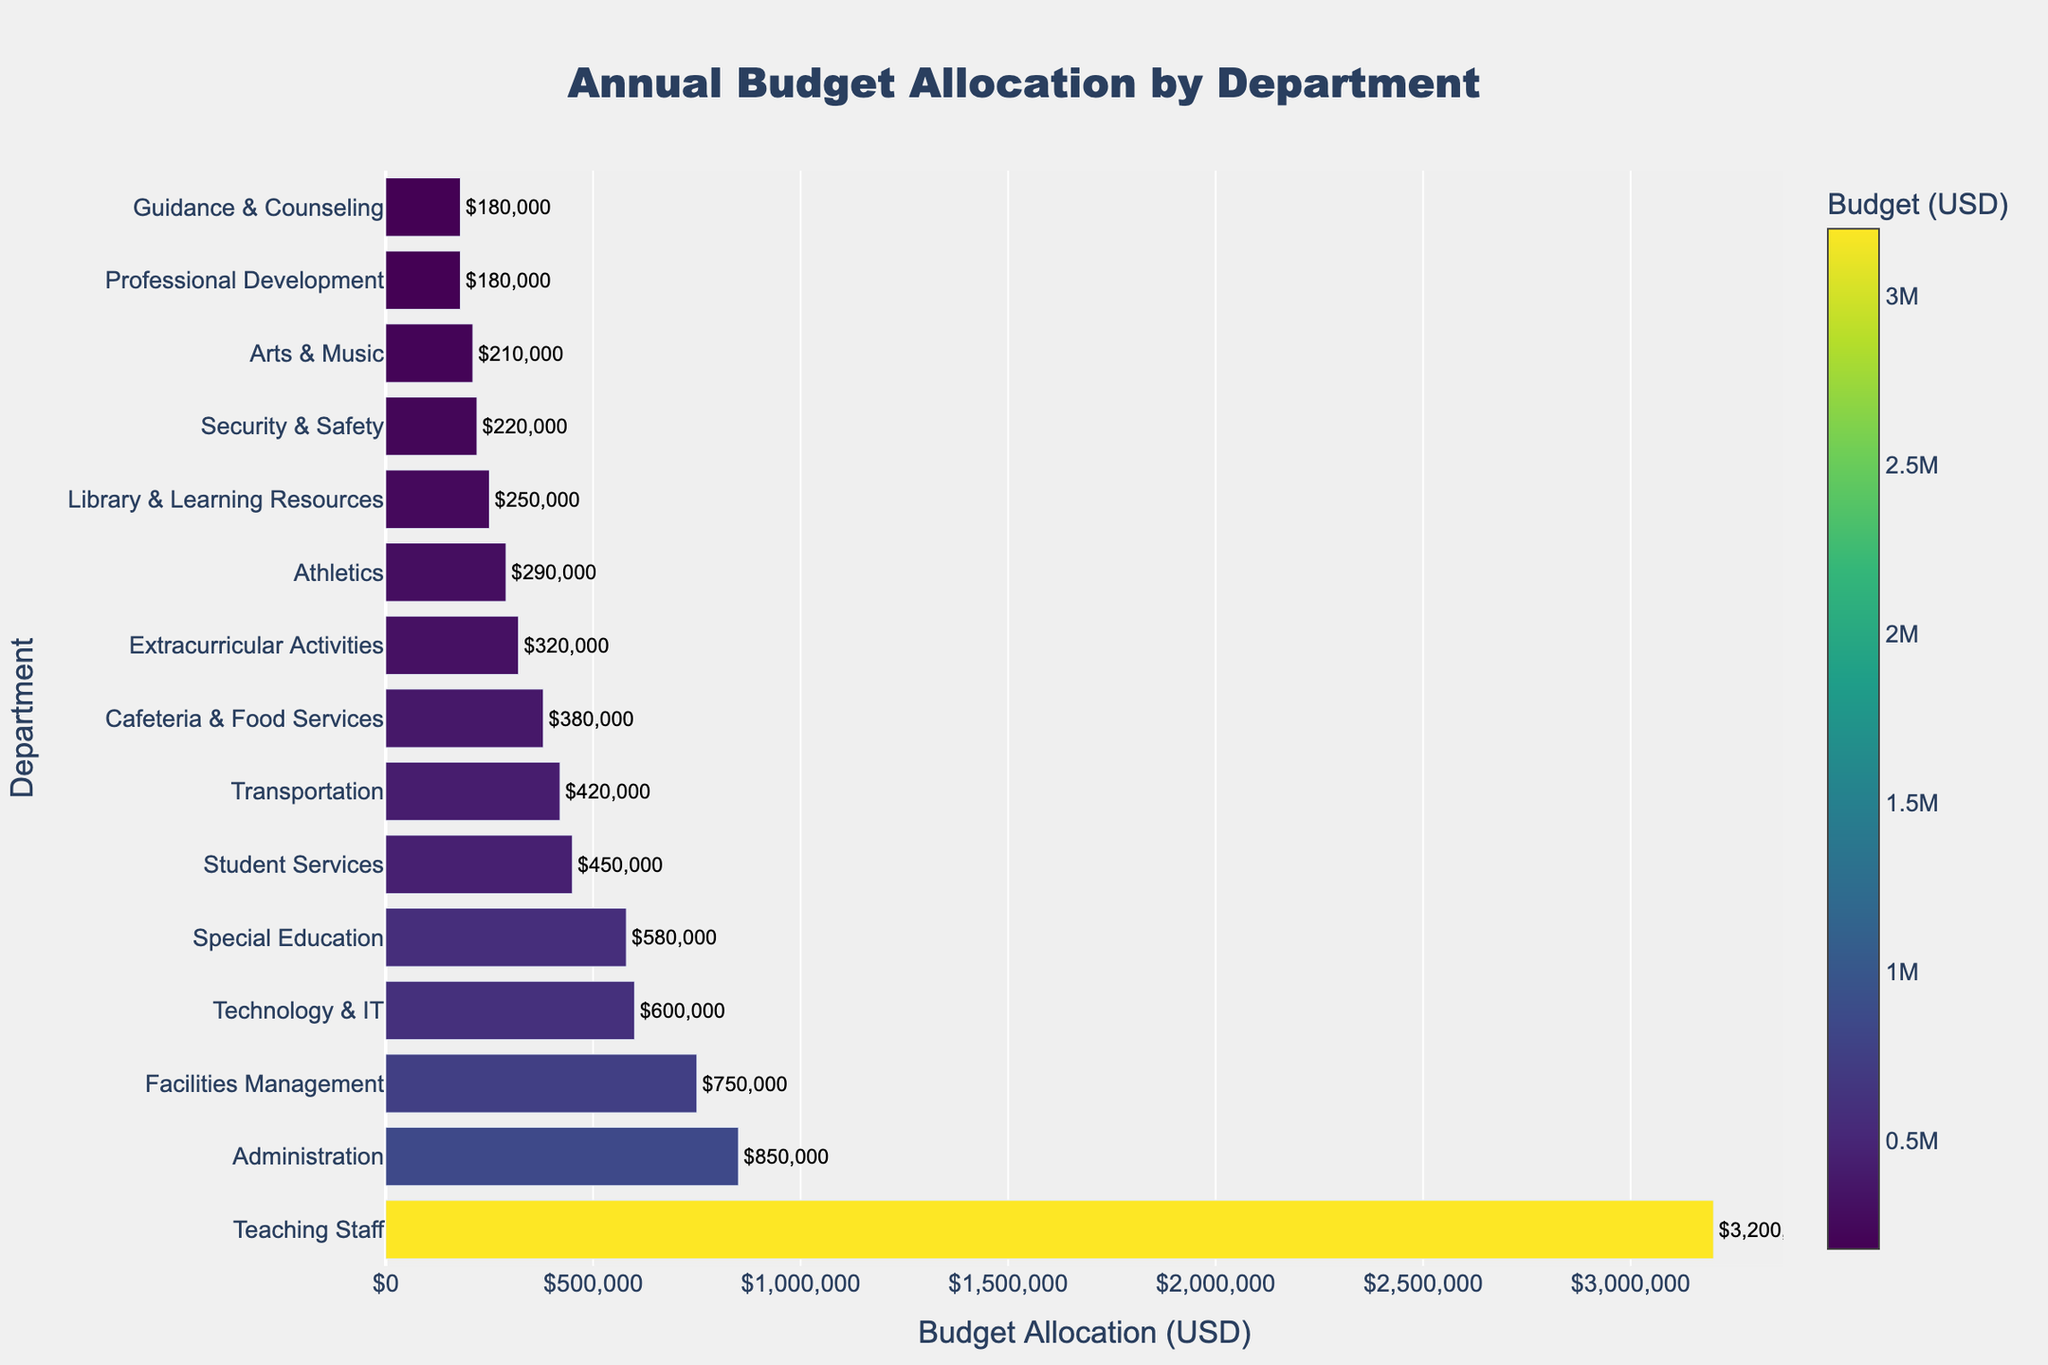What's the total budget allocation for Transportation, Athletics, and Arts & Music combined? To find the total budget allocation for Transportation, Athletics, and Arts & Music, sum their individual allocations: $420,000 + $290,000 + $210,000. The total is $920,000.
Answer: $920,000 Which department has the highest budget allocation? By looking at the lengths of the bars, Teaching Staff has the longest bar. The visual indicator shows that Teaching Staff has the highest budget allocation.
Answer: Teaching Staff How much more is allocated to Teaching Staff compared to Facilities Management? The budget allocation for Teaching Staff is $3,200,000 and for Facilities Management is $750,000. The difference is $3,200,000 - $750,000.
Answer: $2,450,000 Which departments have budget allocations between $200,000 and $400,000? Examining the chart, the departments with budget allocations within this range are Cafeteria & Food Services ($380,000), Athletics ($290,000), Arts & Music ($210,000), and Security & Safety ($220,000).
Answer: Cafeteria & Food Services, Athletics, Arts & Music, Security & Safety Compare the budget allocation for Special Education and Technology & IT. Which one has a higher allocation and by how much? Special Education has a budget allocation of $580,000 and Technology & IT has $600,000. Technology & IT has a higher allocation by $600,000 - $580,000.
Answer: Technology & IT, $20,000 What is the average budget allocation for all departments? To find the average, sum all budget allocations and divide by the number of departments. The total budget allocation is $3200000 + $850000 + $750000 + $600000 + $450000 + $320000 + $180000 + $250000 + $580000 + $220000 + $380000 + $420000 + $290000 + $210000 + $180000 = $8810000. There are 15 departments, so the average is $8810000 / 15.
Answer: $587,333.33 Which department's budget is closest to the median budget allocation? To find the median, list all budget allocations in order: $180,000, $180,000, $210,000, $220,000, $250,000, $290,000, $320,000, $380,000, $420,000, $450,000, $580,000, $600,000, $750,000, $850,000, $3,200,000. The median budget is the middle value, which is $380,000.
Answer: Cafeteria & Food Services What percentage of the total budget is allocated to Administration? First calculate the total budget, which is $8810000. Then divide the Administration budget by the total budget and multiply by 100: ($850,000 / $8810000) * 100.
Answer: 9.65% How does the budget allocation for Library & Learning Resources compare with Guidance & Counseling? Library & Learning Resources has a budget allocation of $250,000 while Guidance & Counseling has $180,000. The difference is $250,000 - $180,000.
Answer: $70,000 Is the budget allocation for Student Services higher than that for Special Education? The budget allocation for Student Services is $450,000 and for Special Education is $580,000. Since $450,000 < $580,000, the allocation for Student Services is not higher.
Answer: No 